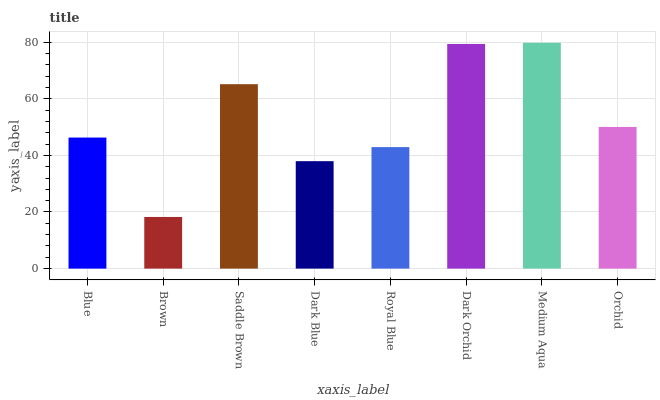Is Brown the minimum?
Answer yes or no. Yes. Is Medium Aqua the maximum?
Answer yes or no. Yes. Is Saddle Brown the minimum?
Answer yes or no. No. Is Saddle Brown the maximum?
Answer yes or no. No. Is Saddle Brown greater than Brown?
Answer yes or no. Yes. Is Brown less than Saddle Brown?
Answer yes or no. Yes. Is Brown greater than Saddle Brown?
Answer yes or no. No. Is Saddle Brown less than Brown?
Answer yes or no. No. Is Orchid the high median?
Answer yes or no. Yes. Is Blue the low median?
Answer yes or no. Yes. Is Saddle Brown the high median?
Answer yes or no. No. Is Saddle Brown the low median?
Answer yes or no. No. 